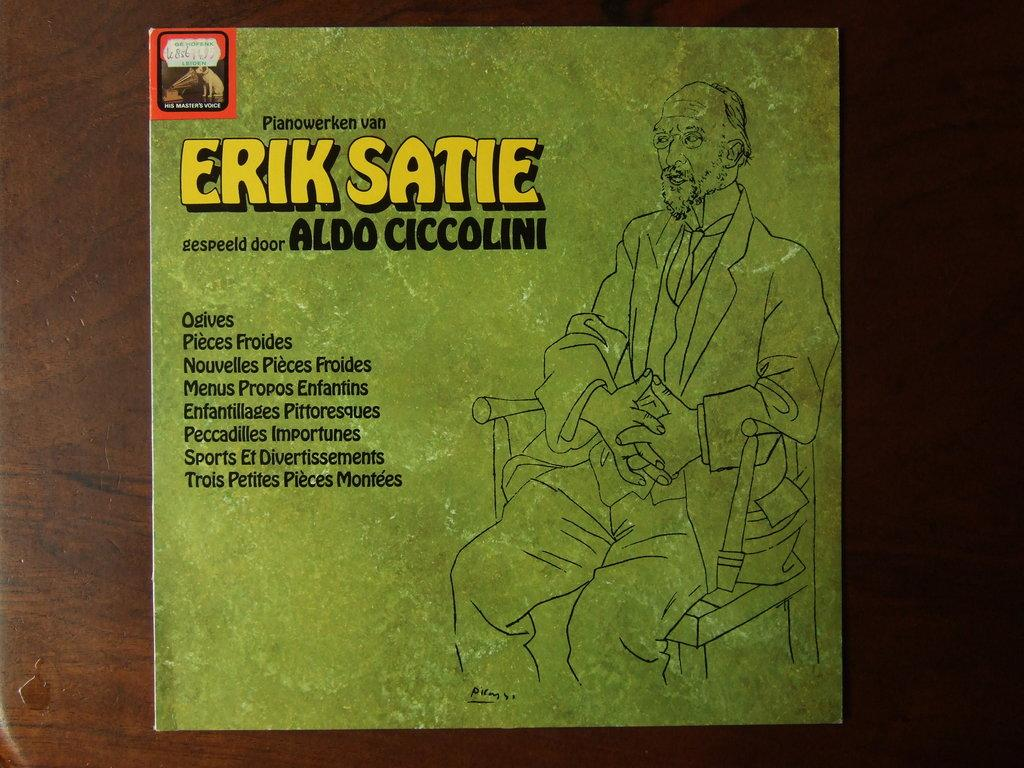<image>
Render a clear and concise summary of the photo. A record album by Erik Satie shows a man seated in a chair. 